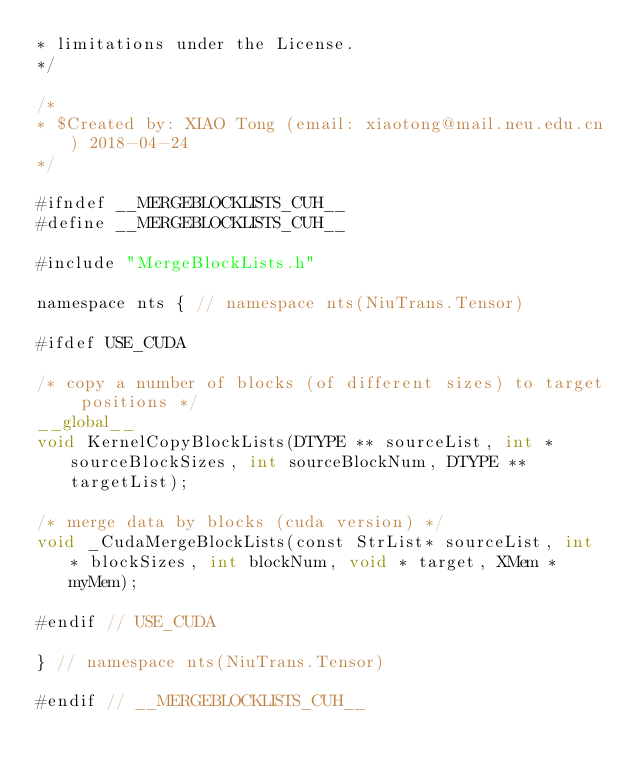<code> <loc_0><loc_0><loc_500><loc_500><_Cuda_>* limitations under the License.
*/

/*
* $Created by: XIAO Tong (email: xiaotong@mail.neu.edu.cn) 2018-04-24
*/

#ifndef __MERGEBLOCKLISTS_CUH__
#define __MERGEBLOCKLISTS_CUH__

#include "MergeBlockLists.h"

namespace nts { // namespace nts(NiuTrans.Tensor)

#ifdef USE_CUDA

/* copy a number of blocks (of different sizes) to target positions */
__global__
void KernelCopyBlockLists(DTYPE ** sourceList, int * sourceBlockSizes, int sourceBlockNum, DTYPE ** targetList);

/* merge data by blocks (cuda version) */
void _CudaMergeBlockLists(const StrList* sourceList, int * blockSizes, int blockNum, void * target, XMem * myMem);

#endif // USE_CUDA

} // namespace nts(NiuTrans.Tensor)

#endif // __MERGEBLOCKLISTS_CUH__

</code> 